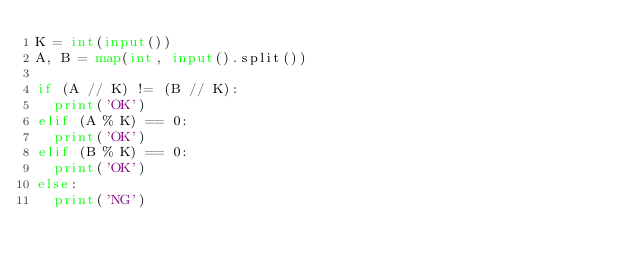<code> <loc_0><loc_0><loc_500><loc_500><_Python_>K = int(input())
A, B = map(int, input().split())

if (A // K) != (B // K):
  print('OK')
elif (A % K) == 0:
  print('OK')
elif (B % K) == 0:
  print('OK')
else:
  print('NG')
</code> 